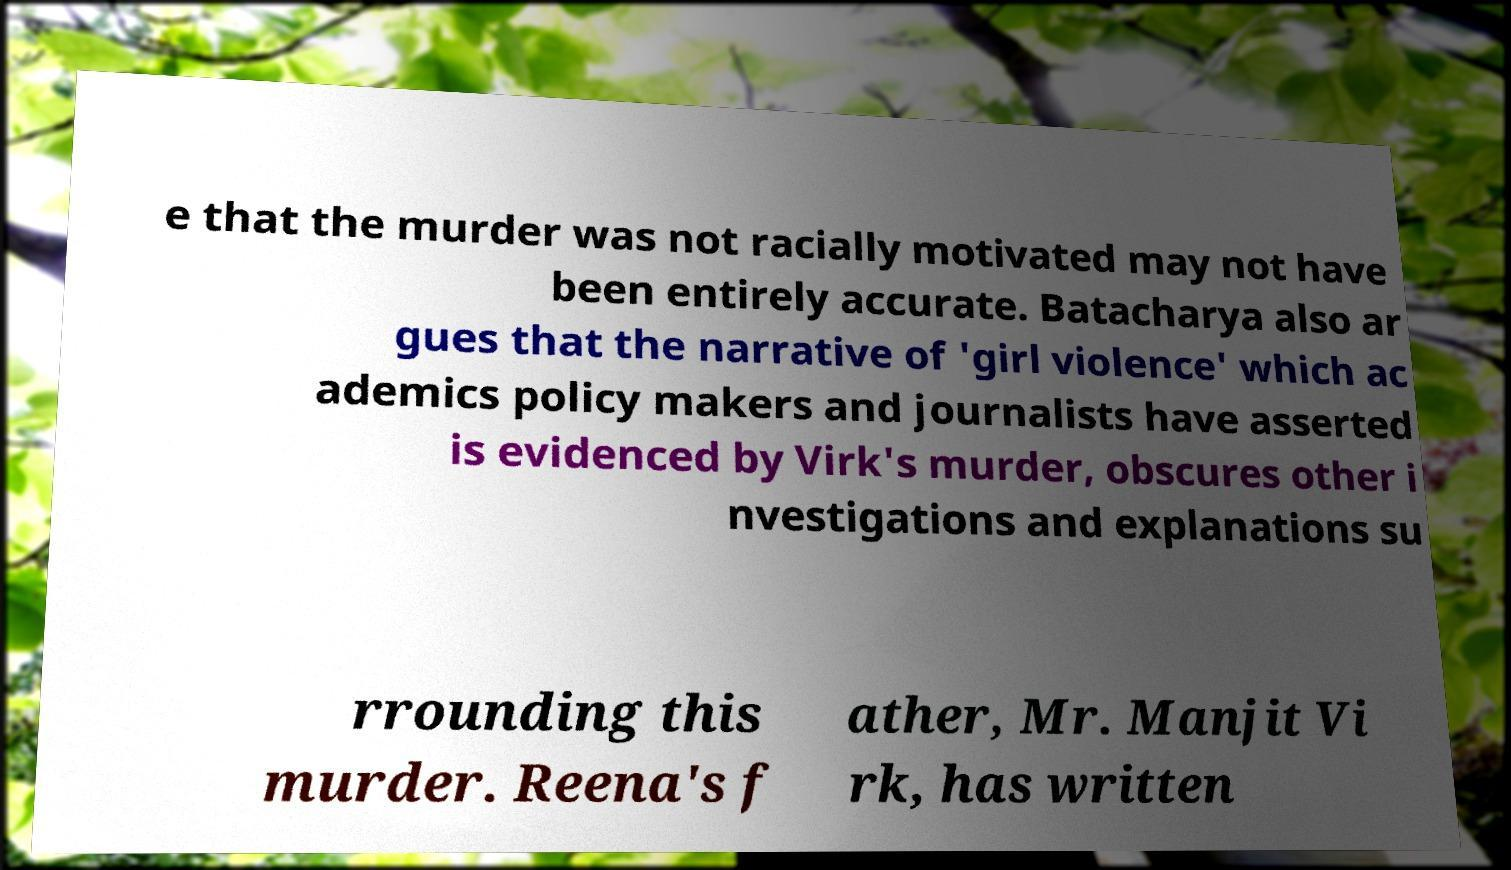Could you extract and type out the text from this image? e that the murder was not racially motivated may not have been entirely accurate. Batacharya also ar gues that the narrative of 'girl violence' which ac ademics policy makers and journalists have asserted is evidenced by Virk's murder, obscures other i nvestigations and explanations su rrounding this murder. Reena's f ather, Mr. Manjit Vi rk, has written 